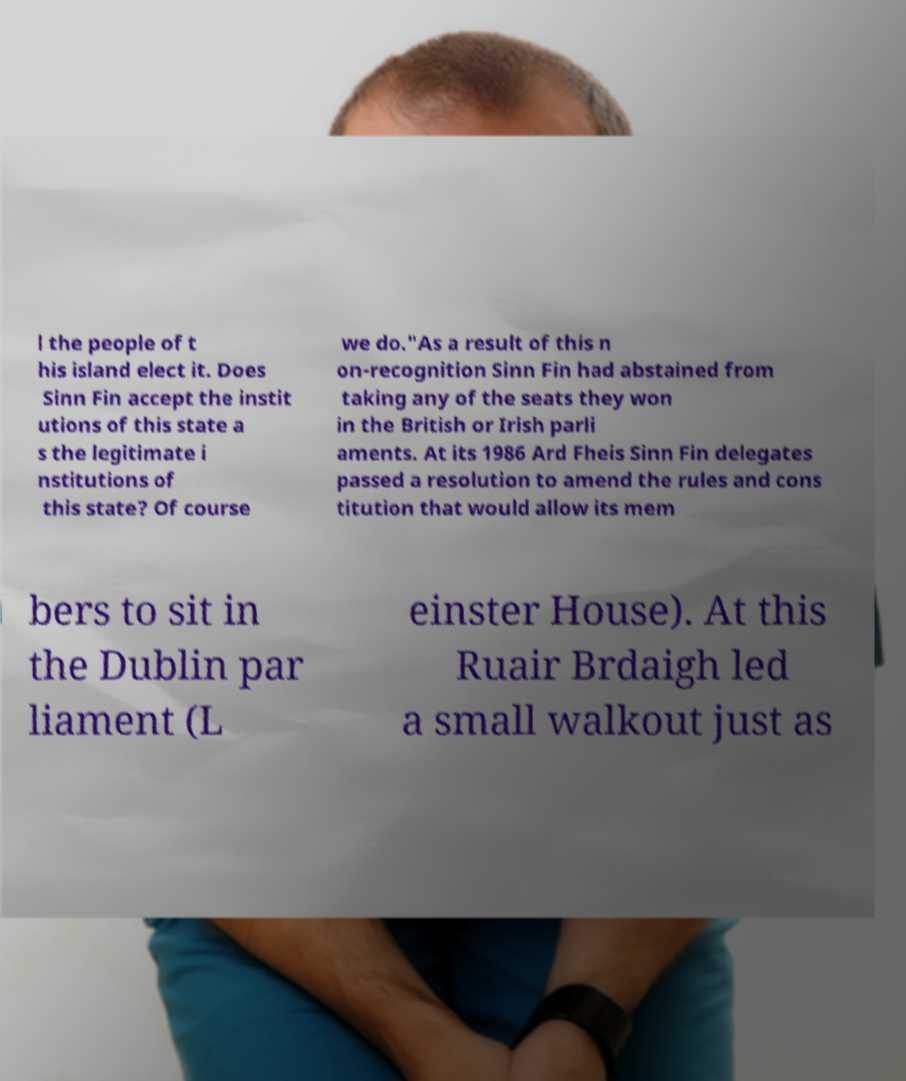Can you accurately transcribe the text from the provided image for me? l the people of t his island elect it. Does Sinn Fin accept the instit utions of this state a s the legitimate i nstitutions of this state? Of course we do."As a result of this n on-recognition Sinn Fin had abstained from taking any of the seats they won in the British or Irish parli aments. At its 1986 Ard Fheis Sinn Fin delegates passed a resolution to amend the rules and cons titution that would allow its mem bers to sit in the Dublin par liament (L einster House). At this Ruair Brdaigh led a small walkout just as 